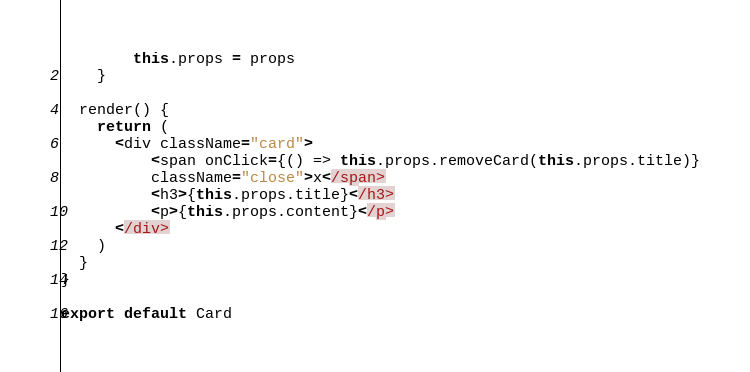Convert code to text. <code><loc_0><loc_0><loc_500><loc_500><_JavaScript_>        this.props = props
    }

  render() {
    return (
      <div className="card">
          <span onClick={() => this.props.removeCard(this.props.title)}
          className="close">x</span>
          <h3>{this.props.title}</h3>
          <p>{this.props.content}</p>
      </div>
    )
  }
}

export default Card</code> 